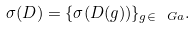<formula> <loc_0><loc_0><loc_500><loc_500>\sigma ( D ) = \{ \sigma ( D ( g ) ) \} _ { g \in \ G a } .</formula> 